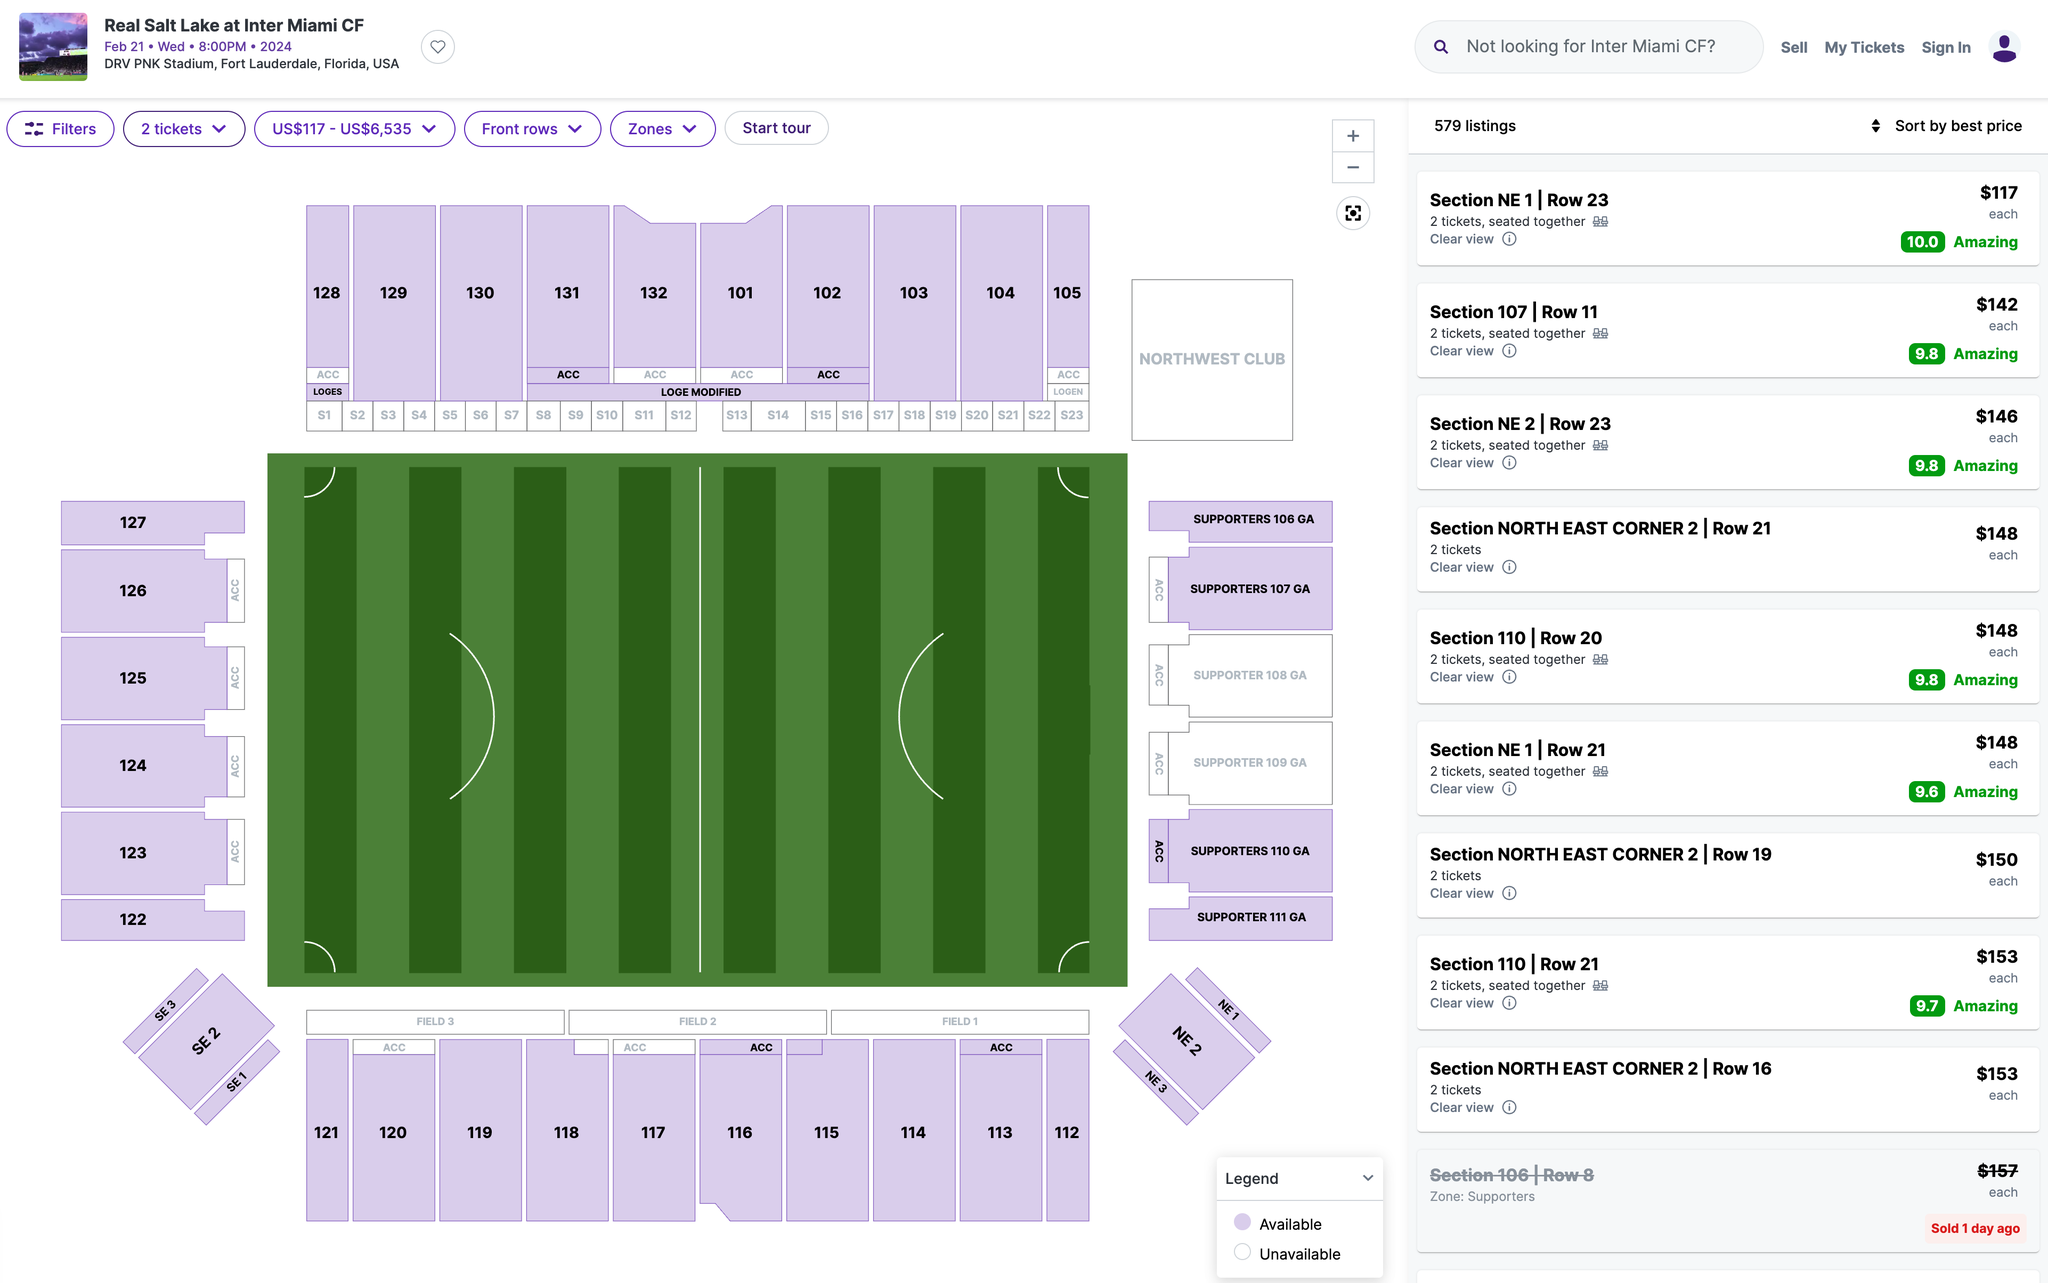Which section's ticket would you recommend I purchase? I recommend purchasing tickets in Section 107. This section is located on the west side of the stadium, and it offers a great view of the field. Additionally, this section is relatively close to the action, so you'll be able to feel the excitement of the game. 